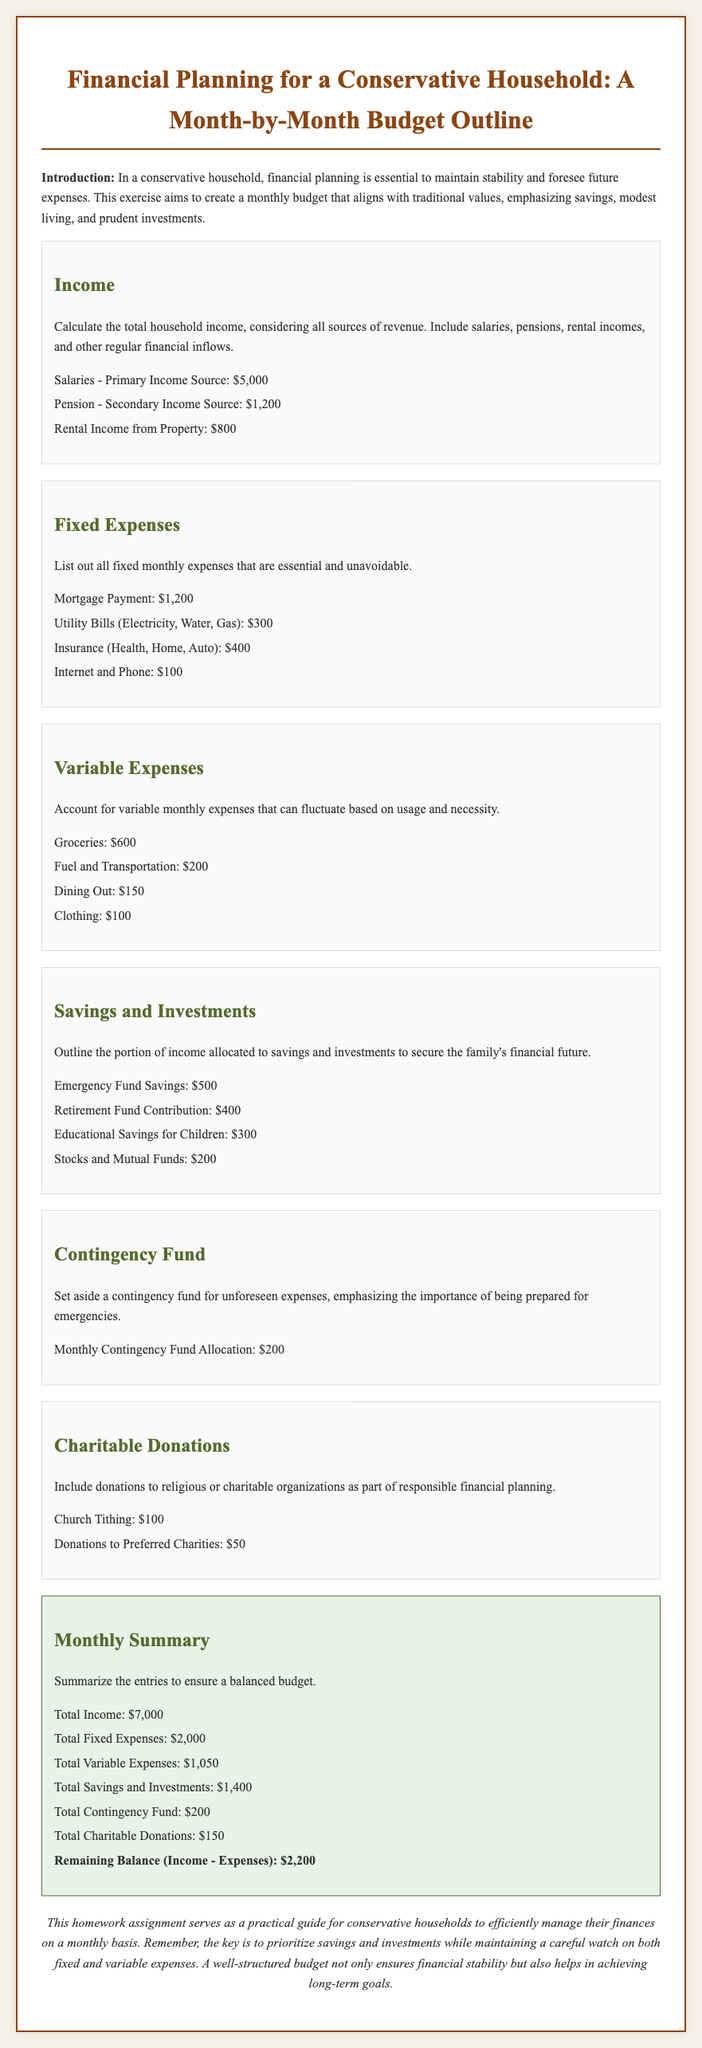what is the primary income source? The primary income source listed in the document is the salary amounting to $5,000.
Answer: $5,000 how much is allocated for groceries? The document states that the amount allocated for groceries is $600.
Answer: $600 what is the total fixed expenses? The total fixed expenses are calculated to be the sum of all listed fixed expenses, which is $2,000.
Answer: $2,000 what percentage of total income is allocated to savings? The total savings and investments of $1,400 represent approximately 20% of the total income of $7,000.
Answer: 20% what is the amount set for the contingency fund? The monthly contingency fund allocation mentioned in the document is $200.
Answer: $200 how much is earmarked for charitable donations? The document specifies the total amount of charitable donations as $150.
Answer: $150 what remains after calculating total income minus total expenses? The remaining balance, after subtracting total expenses from total income, is $2,200.
Answer: $2,200 what is the primary focus of this budget outline? The primary focus of the budget outline is to ensure financial stability by maintaining a structured budget centered on savings.
Answer: financial stability 